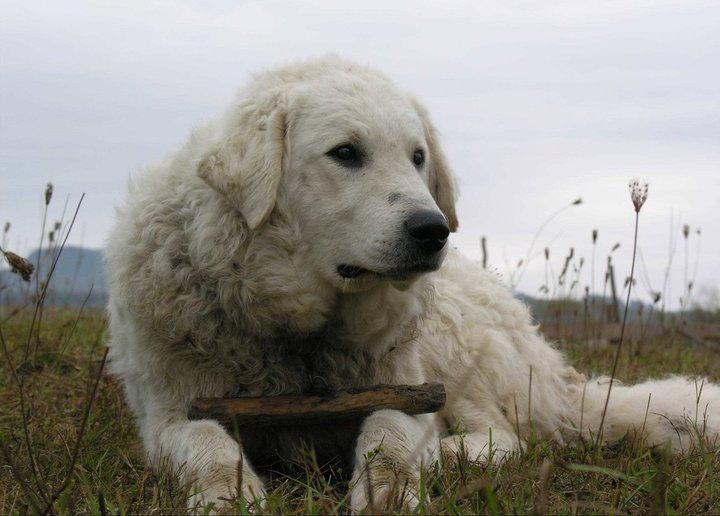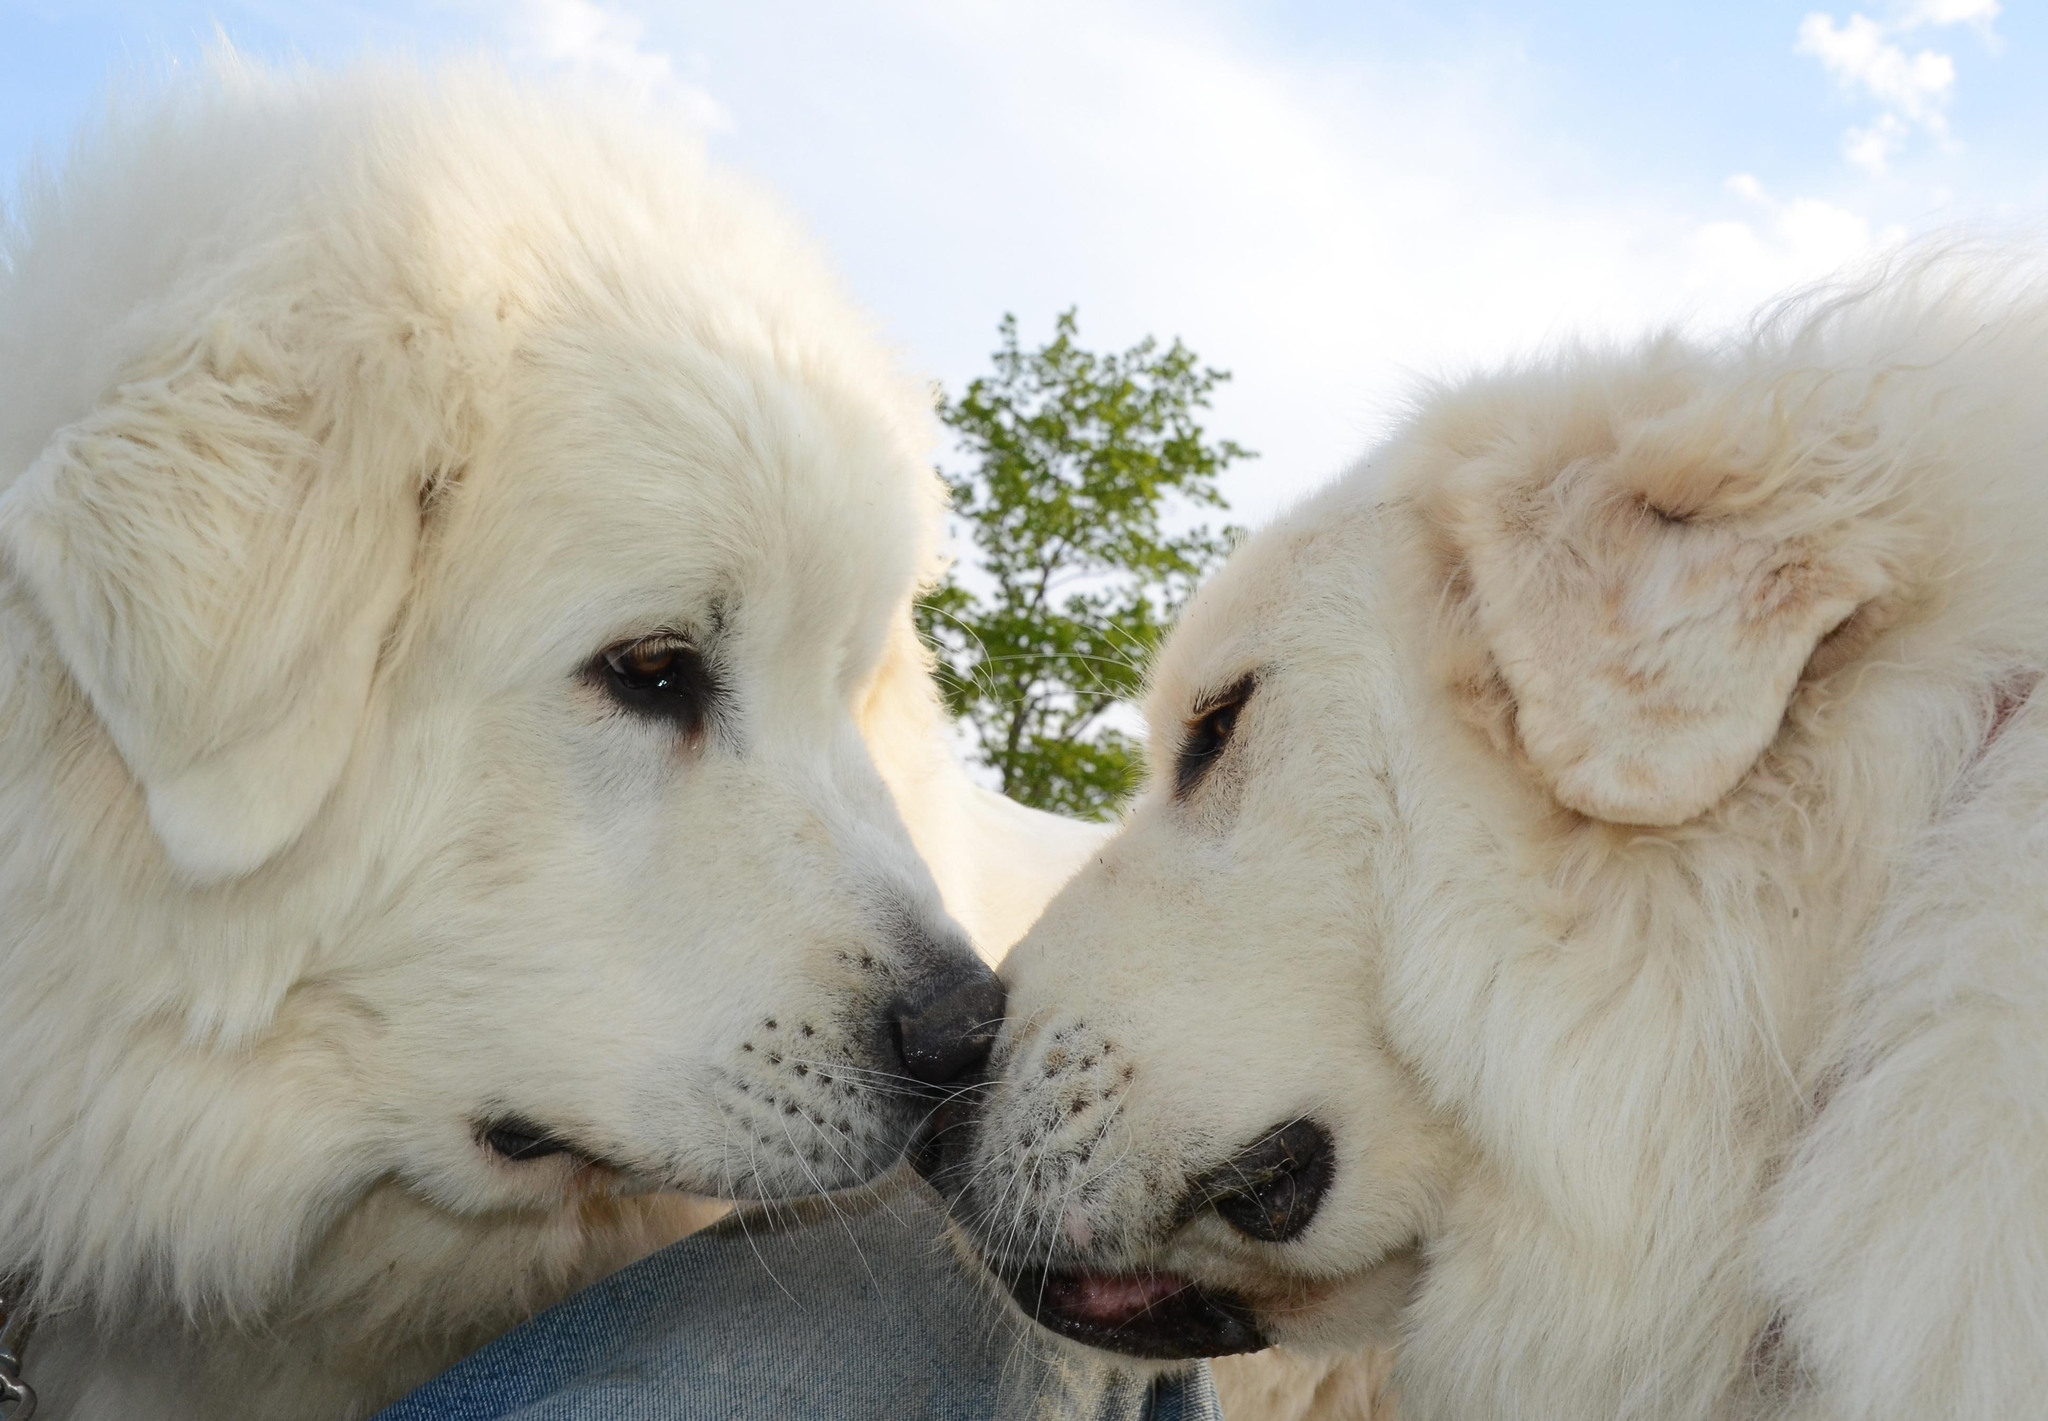The first image is the image on the left, the second image is the image on the right. Analyze the images presented: Is the assertion "There are three dogs in total." valid? Answer yes or no. Yes. 